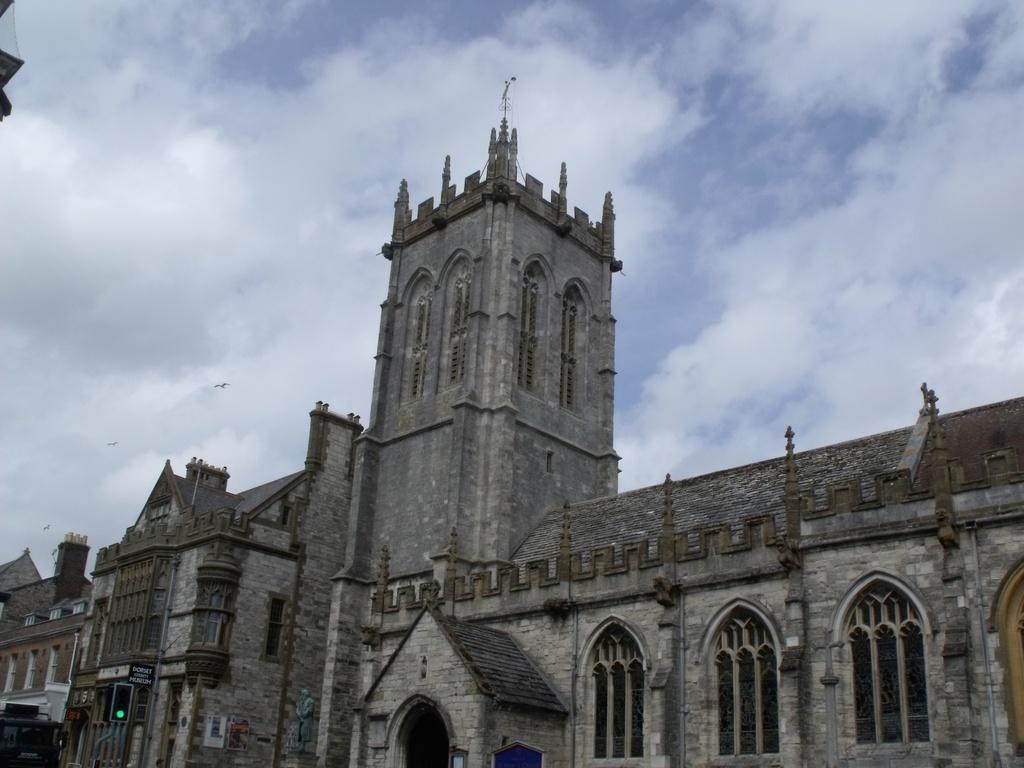Can you describe this image briefly? In this picture there is a building and the sky is cloudy. 